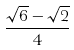Convert formula to latex. <formula><loc_0><loc_0><loc_500><loc_500>\frac { \sqrt { 6 } - \sqrt { 2 } } { 4 }</formula> 